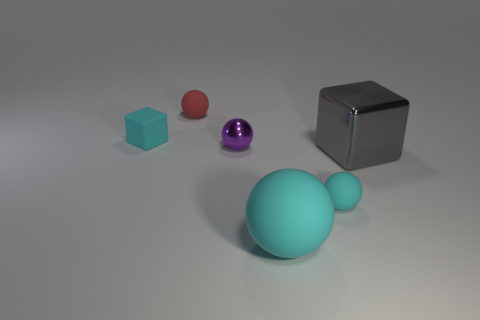Subtract all tiny red spheres. How many spheres are left? 3 Add 3 small metal things. How many objects exist? 9 Subtract all balls. How many objects are left? 2 Subtract all blue cylinders. How many cyan spheres are left? 2 Subtract all purple balls. How many balls are left? 3 Subtract 1 balls. How many balls are left? 3 Add 6 rubber things. How many rubber things are left? 10 Add 2 tiny cubes. How many tiny cubes exist? 3 Subtract 0 brown balls. How many objects are left? 6 Subtract all cyan balls. Subtract all green cylinders. How many balls are left? 2 